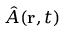<formula> <loc_0><loc_0><loc_500><loc_500>\hat { A } ( { r } , t )</formula> 